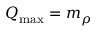Convert formula to latex. <formula><loc_0><loc_0><loc_500><loc_500>Q _ { \max } = m _ { \rho }</formula> 